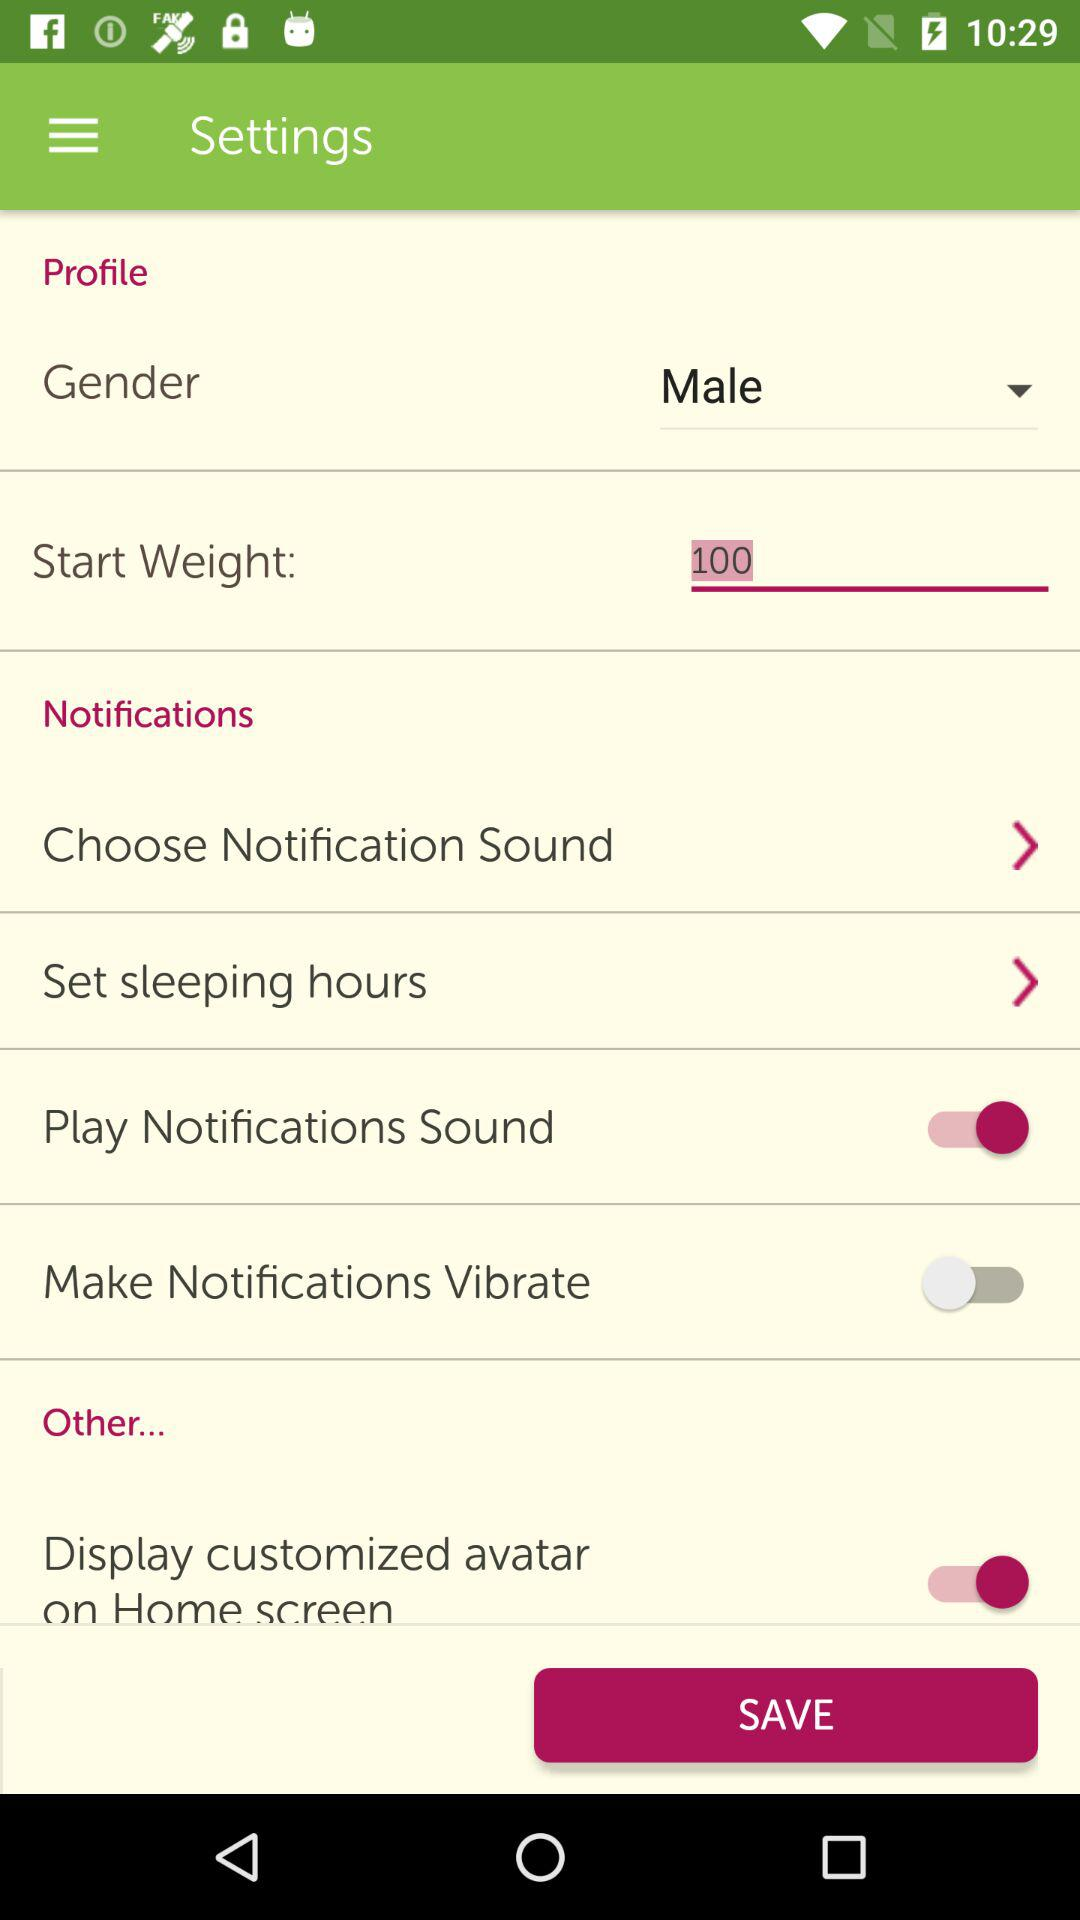What is the status of the "Play Notifications Sound"? The status is "on". 